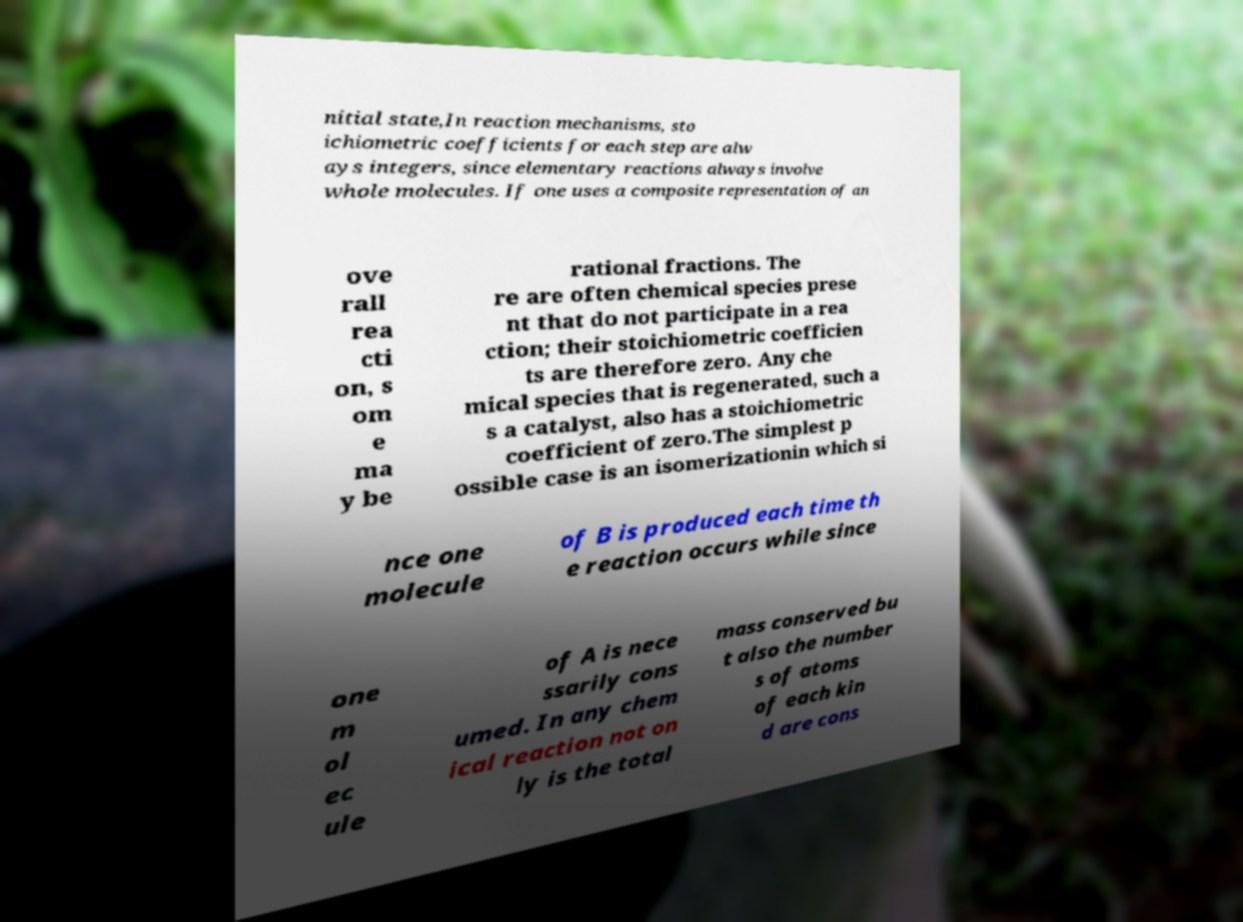For documentation purposes, I need the text within this image transcribed. Could you provide that? nitial state,In reaction mechanisms, sto ichiometric coefficients for each step are alw ays integers, since elementary reactions always involve whole molecules. If one uses a composite representation of an ove rall rea cti on, s om e ma y be rational fractions. The re are often chemical species prese nt that do not participate in a rea ction; their stoichiometric coefficien ts are therefore zero. Any che mical species that is regenerated, such a s a catalyst, also has a stoichiometric coefficient of zero.The simplest p ossible case is an isomerizationin which si nce one molecule of B is produced each time th e reaction occurs while since one m ol ec ule of A is nece ssarily cons umed. In any chem ical reaction not on ly is the total mass conserved bu t also the number s of atoms of each kin d are cons 